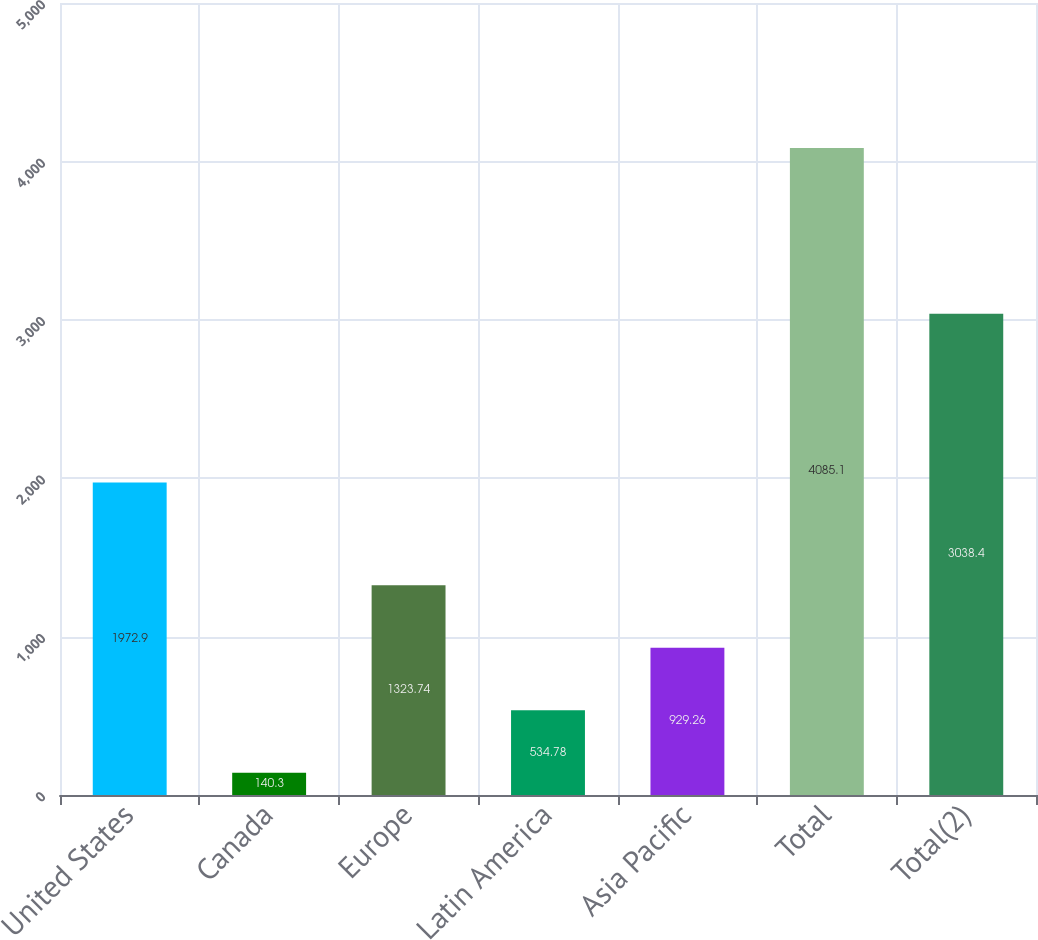<chart> <loc_0><loc_0><loc_500><loc_500><bar_chart><fcel>United States<fcel>Canada<fcel>Europe<fcel>Latin America<fcel>Asia Pacific<fcel>Total<fcel>Total(2)<nl><fcel>1972.9<fcel>140.3<fcel>1323.74<fcel>534.78<fcel>929.26<fcel>4085.1<fcel>3038.4<nl></chart> 